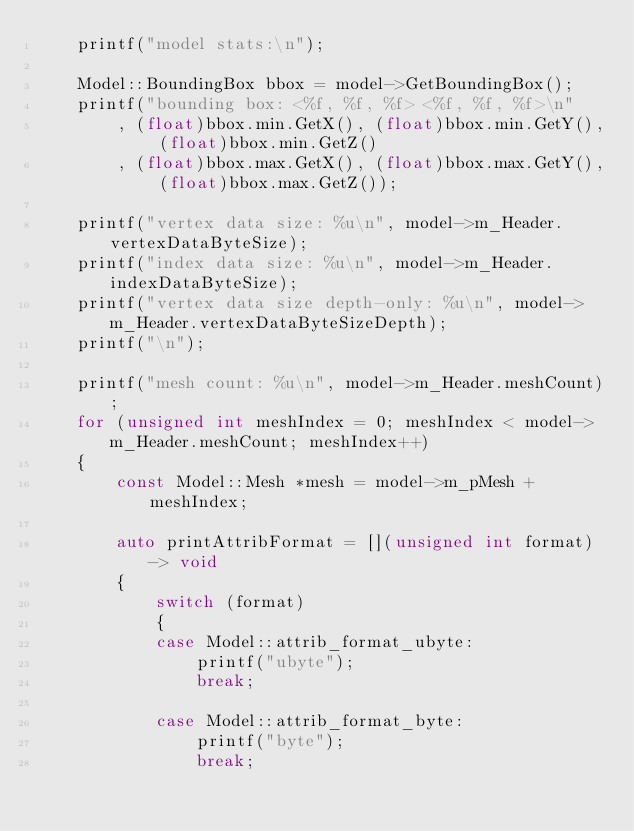Convert code to text. <code><loc_0><loc_0><loc_500><loc_500><_C++_>    printf("model stats:\n");
    
    Model::BoundingBox bbox = model->GetBoundingBox();
    printf("bounding box: <%f, %f, %f> <%f, %f, %f>\n"
        , (float)bbox.min.GetX(), (float)bbox.min.GetY(), (float)bbox.min.GetZ()
        , (float)bbox.max.GetX(), (float)bbox.max.GetY(), (float)bbox.max.GetZ());

    printf("vertex data size: %u\n", model->m_Header.vertexDataByteSize);
    printf("index data size: %u\n", model->m_Header.indexDataByteSize);
    printf("vertex data size depth-only: %u\n", model->m_Header.vertexDataByteSizeDepth);
    printf("\n");

    printf("mesh count: %u\n", model->m_Header.meshCount);
    for (unsigned int meshIndex = 0; meshIndex < model->m_Header.meshCount; meshIndex++)
    {
        const Model::Mesh *mesh = model->m_pMesh + meshIndex;

        auto printAttribFormat = [](unsigned int format) -> void
        {
            switch (format)
            {
            case Model::attrib_format_ubyte:
                printf("ubyte");
                break;

            case Model::attrib_format_byte:
                printf("byte");
                break;
</code> 